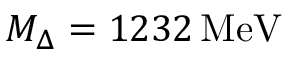<formula> <loc_0><loc_0><loc_500><loc_500>M _ { \Delta } = 1 2 3 2 \, M e V</formula> 